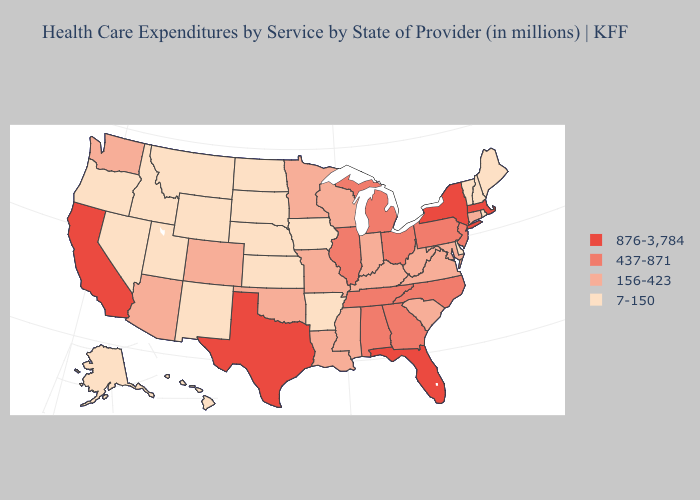What is the lowest value in states that border West Virginia?
Answer briefly. 156-423. Does New Jersey have the lowest value in the Northeast?
Give a very brief answer. No. Among the states that border Kentucky , does Indiana have the highest value?
Short answer required. No. How many symbols are there in the legend?
Concise answer only. 4. Does South Carolina have the same value as Connecticut?
Be succinct. Yes. What is the lowest value in states that border Idaho?
Be succinct. 7-150. What is the highest value in the USA?
Quick response, please. 876-3,784. What is the value of Washington?
Concise answer only. 156-423. Among the states that border Missouri , which have the highest value?
Answer briefly. Illinois, Tennessee. Which states have the lowest value in the USA?
Answer briefly. Alaska, Arkansas, Delaware, Hawaii, Idaho, Iowa, Kansas, Maine, Montana, Nebraska, Nevada, New Hampshire, New Mexico, North Dakota, Oregon, Rhode Island, South Dakota, Utah, Vermont, Wyoming. What is the value of New York?
Keep it brief. 876-3,784. What is the value of Ohio?
Short answer required. 437-871. Among the states that border California , which have the lowest value?
Short answer required. Nevada, Oregon. What is the value of Oregon?
Write a very short answer. 7-150. What is the value of Wisconsin?
Quick response, please. 156-423. 